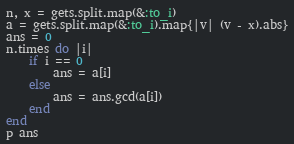Convert code to text. <code><loc_0><loc_0><loc_500><loc_500><_Ruby_>n, x = gets.split.map(&:to_i)
a = gets.split.map(&:to_i).map{|v| (v - x).abs}
ans = 0
n.times do |i|
    if i == 0
        ans = a[i]
    else
        ans = ans.gcd(a[i])
    end
end
p ans</code> 